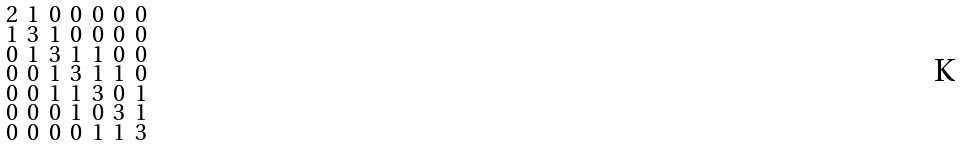Convert formula to latex. <formula><loc_0><loc_0><loc_500><loc_500>\begin{smallmatrix} 2 & 1 & 0 & 0 & 0 & 0 & 0 \\ 1 & 3 & 1 & 0 & 0 & 0 & 0 \\ 0 & 1 & 3 & 1 & 1 & 0 & 0 \\ 0 & 0 & 1 & 3 & 1 & 1 & 0 \\ 0 & 0 & 1 & 1 & 3 & 0 & 1 \\ 0 & 0 & 0 & 1 & 0 & 3 & 1 \\ 0 & 0 & 0 & 0 & 1 & 1 & 3 \end{smallmatrix}</formula> 